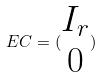<formula> <loc_0><loc_0><loc_500><loc_500>E C = ( \begin{matrix} I _ { r } \\ 0 \end{matrix} )</formula> 